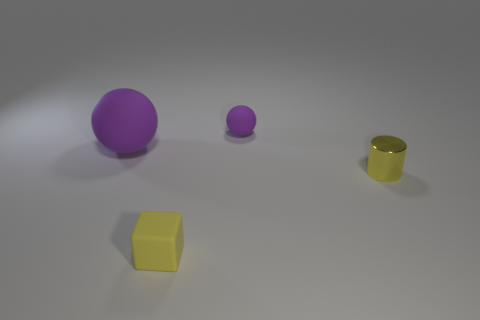Add 3 blocks. How many objects exist? 7 Subtract all cubes. How many objects are left? 3 Subtract all big yellow spheres. Subtract all big rubber objects. How many objects are left? 3 Add 1 small rubber things. How many small rubber things are left? 3 Add 1 rubber cylinders. How many rubber cylinders exist? 1 Subtract 0 gray cylinders. How many objects are left? 4 